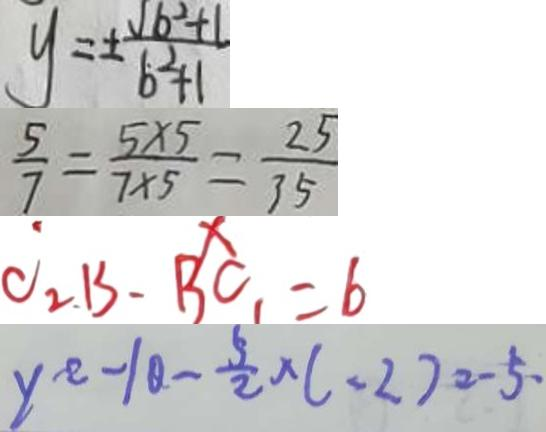Convert formula to latex. <formula><loc_0><loc_0><loc_500><loc_500>y = \pm \frac { \sqrt { b ^ { 2 } + 1 } } { b ^ { 2 } + 1 } 
 \frac { 5 } { 7 } = \frac { 5 \times 5 } { 7 \times 5 } = \frac { 2 5 } { 3 5 } 
 C _ { 2 } B - B C _ { 1 } = 6 
 y ^ { 2 } - 1 0 - \frac { 5 } { 2 } \times ( - 2 ) = - 5 .</formula> 